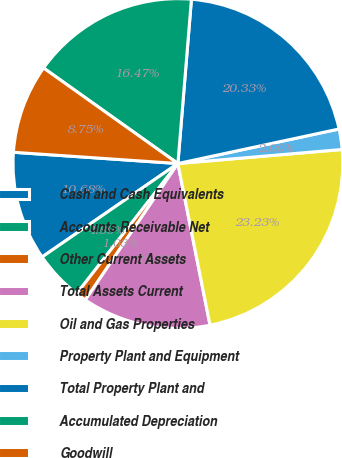Convert chart. <chart><loc_0><loc_0><loc_500><loc_500><pie_chart><fcel>Cash and Cash Equivalents<fcel>Accounts Receivable Net<fcel>Other Current Assets<fcel>Total Assets Current<fcel>Oil and Gas Properties<fcel>Property Plant and Equipment<fcel>Total Property Plant and<fcel>Accumulated Depreciation<fcel>Goodwill<nl><fcel>10.68%<fcel>4.89%<fcel>1.03%<fcel>12.61%<fcel>23.23%<fcel>2.0%<fcel>20.33%<fcel>16.47%<fcel>8.75%<nl></chart> 